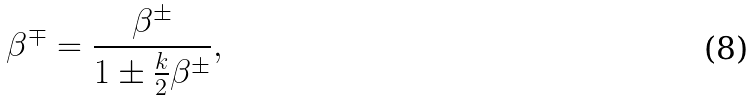Convert formula to latex. <formula><loc_0><loc_0><loc_500><loc_500>\beta ^ { \mp } = \frac { \beta ^ { \pm } } { 1 \pm \frac { k } { 2 } \beta ^ { \pm } } ,</formula> 